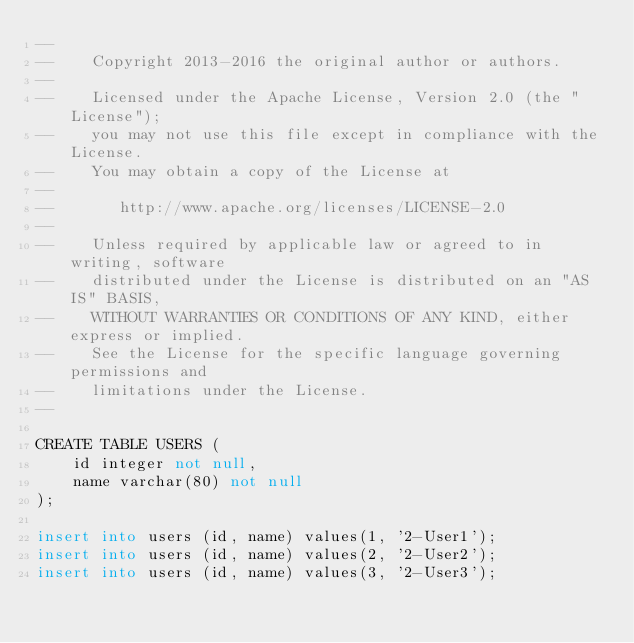<code> <loc_0><loc_0><loc_500><loc_500><_SQL_>--
--    Copyright 2013-2016 the original author or authors.
--
--    Licensed under the Apache License, Version 2.0 (the "License");
--    you may not use this file except in compliance with the License.
--    You may obtain a copy of the License at
--
--       http://www.apache.org/licenses/LICENSE-2.0
--
--    Unless required by applicable law or agreed to in writing, software
--    distributed under the License is distributed on an "AS IS" BASIS,
--    WITHOUT WARRANTIES OR CONDITIONS OF ANY KIND, either express or implied.
--    See the License for the specific language governing permissions and
--    limitations under the License.
--

CREATE TABLE USERS (
    id integer not null,
    name varchar(80) not null
);

insert into users (id, name) values(1, '2-User1');
insert into users (id, name) values(2, '2-User2');
insert into users (id, name) values(3, '2-User3');
</code> 